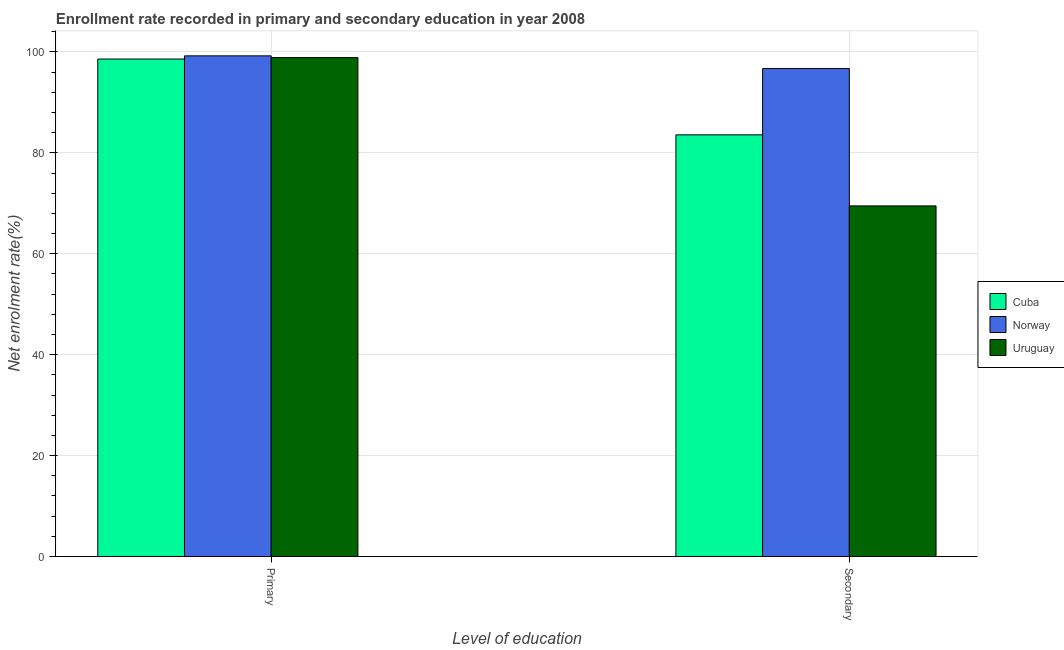How many different coloured bars are there?
Your answer should be compact. 3. How many groups of bars are there?
Give a very brief answer. 2. How many bars are there on the 2nd tick from the left?
Provide a short and direct response. 3. What is the label of the 2nd group of bars from the left?
Ensure brevity in your answer.  Secondary. What is the enrollment rate in secondary education in Cuba?
Your response must be concise. 83.57. Across all countries, what is the maximum enrollment rate in primary education?
Make the answer very short. 99.23. Across all countries, what is the minimum enrollment rate in secondary education?
Provide a short and direct response. 69.49. In which country was the enrollment rate in primary education minimum?
Ensure brevity in your answer.  Cuba. What is the total enrollment rate in primary education in the graph?
Give a very brief answer. 296.7. What is the difference between the enrollment rate in primary education in Norway and that in Cuba?
Offer a very short reply. 0.63. What is the difference between the enrollment rate in secondary education in Norway and the enrollment rate in primary education in Uruguay?
Your answer should be compact. -2.17. What is the average enrollment rate in secondary education per country?
Give a very brief answer. 83.26. What is the difference between the enrollment rate in secondary education and enrollment rate in primary education in Uruguay?
Your response must be concise. -29.39. In how many countries, is the enrollment rate in secondary education greater than 20 %?
Ensure brevity in your answer.  3. What is the ratio of the enrollment rate in primary education in Uruguay to that in Cuba?
Provide a succinct answer. 1. What does the 3rd bar from the left in Secondary represents?
Provide a short and direct response. Uruguay. What does the 3rd bar from the right in Primary represents?
Make the answer very short. Cuba. How many bars are there?
Your response must be concise. 6. Are all the bars in the graph horizontal?
Provide a short and direct response. No. How many countries are there in the graph?
Your answer should be compact. 3. Are the values on the major ticks of Y-axis written in scientific E-notation?
Your response must be concise. No. Does the graph contain any zero values?
Provide a succinct answer. No. What is the title of the graph?
Provide a short and direct response. Enrollment rate recorded in primary and secondary education in year 2008. Does "Croatia" appear as one of the legend labels in the graph?
Offer a terse response. No. What is the label or title of the X-axis?
Provide a succinct answer. Level of education. What is the label or title of the Y-axis?
Provide a succinct answer. Net enrolment rate(%). What is the Net enrolment rate(%) of Cuba in Primary?
Provide a short and direct response. 98.6. What is the Net enrolment rate(%) of Norway in Primary?
Give a very brief answer. 99.23. What is the Net enrolment rate(%) in Uruguay in Primary?
Keep it short and to the point. 98.88. What is the Net enrolment rate(%) of Cuba in Secondary?
Your answer should be compact. 83.57. What is the Net enrolment rate(%) of Norway in Secondary?
Your answer should be compact. 96.71. What is the Net enrolment rate(%) in Uruguay in Secondary?
Your answer should be compact. 69.49. Across all Level of education, what is the maximum Net enrolment rate(%) in Cuba?
Offer a terse response. 98.6. Across all Level of education, what is the maximum Net enrolment rate(%) in Norway?
Make the answer very short. 99.23. Across all Level of education, what is the maximum Net enrolment rate(%) in Uruguay?
Keep it short and to the point. 98.88. Across all Level of education, what is the minimum Net enrolment rate(%) of Cuba?
Give a very brief answer. 83.57. Across all Level of education, what is the minimum Net enrolment rate(%) of Norway?
Your response must be concise. 96.71. Across all Level of education, what is the minimum Net enrolment rate(%) of Uruguay?
Your answer should be very brief. 69.49. What is the total Net enrolment rate(%) of Cuba in the graph?
Give a very brief answer. 182.17. What is the total Net enrolment rate(%) of Norway in the graph?
Provide a short and direct response. 195.94. What is the total Net enrolment rate(%) of Uruguay in the graph?
Offer a very short reply. 168.37. What is the difference between the Net enrolment rate(%) in Cuba in Primary and that in Secondary?
Make the answer very short. 15.03. What is the difference between the Net enrolment rate(%) of Norway in Primary and that in Secondary?
Make the answer very short. 2.52. What is the difference between the Net enrolment rate(%) of Uruguay in Primary and that in Secondary?
Your answer should be compact. 29.39. What is the difference between the Net enrolment rate(%) in Cuba in Primary and the Net enrolment rate(%) in Norway in Secondary?
Provide a succinct answer. 1.89. What is the difference between the Net enrolment rate(%) of Cuba in Primary and the Net enrolment rate(%) of Uruguay in Secondary?
Give a very brief answer. 29.1. What is the difference between the Net enrolment rate(%) in Norway in Primary and the Net enrolment rate(%) in Uruguay in Secondary?
Keep it short and to the point. 29.74. What is the average Net enrolment rate(%) of Cuba per Level of education?
Your answer should be very brief. 91.08. What is the average Net enrolment rate(%) of Norway per Level of education?
Make the answer very short. 97.97. What is the average Net enrolment rate(%) in Uruguay per Level of education?
Ensure brevity in your answer.  84.19. What is the difference between the Net enrolment rate(%) in Cuba and Net enrolment rate(%) in Norway in Primary?
Give a very brief answer. -0.63. What is the difference between the Net enrolment rate(%) of Cuba and Net enrolment rate(%) of Uruguay in Primary?
Provide a succinct answer. -0.28. What is the difference between the Net enrolment rate(%) in Norway and Net enrolment rate(%) in Uruguay in Primary?
Provide a short and direct response. 0.35. What is the difference between the Net enrolment rate(%) in Cuba and Net enrolment rate(%) in Norway in Secondary?
Make the answer very short. -13.14. What is the difference between the Net enrolment rate(%) of Cuba and Net enrolment rate(%) of Uruguay in Secondary?
Your answer should be very brief. 14.08. What is the difference between the Net enrolment rate(%) of Norway and Net enrolment rate(%) of Uruguay in Secondary?
Your answer should be compact. 27.22. What is the ratio of the Net enrolment rate(%) in Cuba in Primary to that in Secondary?
Provide a succinct answer. 1.18. What is the ratio of the Net enrolment rate(%) in Uruguay in Primary to that in Secondary?
Offer a terse response. 1.42. What is the difference between the highest and the second highest Net enrolment rate(%) in Cuba?
Provide a succinct answer. 15.03. What is the difference between the highest and the second highest Net enrolment rate(%) of Norway?
Offer a very short reply. 2.52. What is the difference between the highest and the second highest Net enrolment rate(%) in Uruguay?
Give a very brief answer. 29.39. What is the difference between the highest and the lowest Net enrolment rate(%) of Cuba?
Ensure brevity in your answer.  15.03. What is the difference between the highest and the lowest Net enrolment rate(%) of Norway?
Keep it short and to the point. 2.52. What is the difference between the highest and the lowest Net enrolment rate(%) in Uruguay?
Offer a terse response. 29.39. 